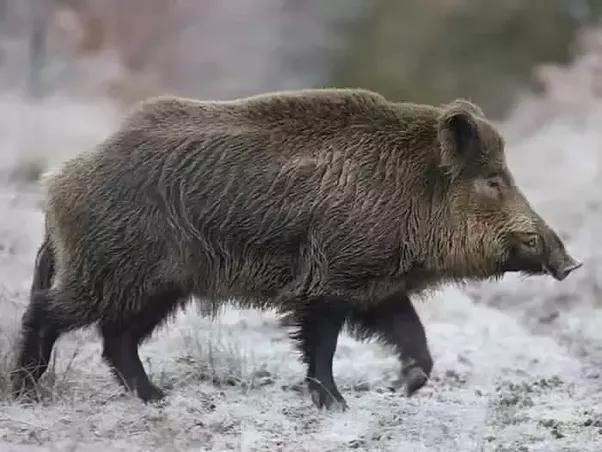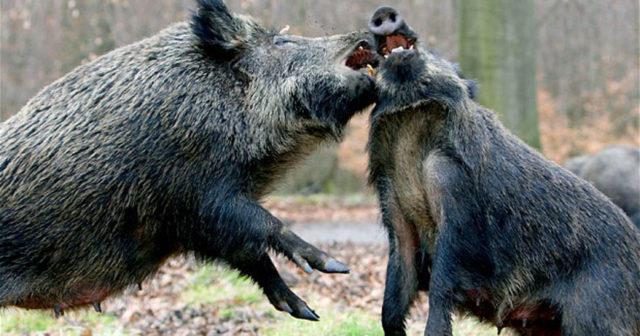The first image is the image on the left, the second image is the image on the right. Examine the images to the left and right. Is the description "An image shows one walking boar in full head and body profile." accurate? Answer yes or no. Yes. The first image is the image on the left, the second image is the image on the right. Given the left and right images, does the statement "There are at most 3 hogs total." hold true? Answer yes or no. Yes. 